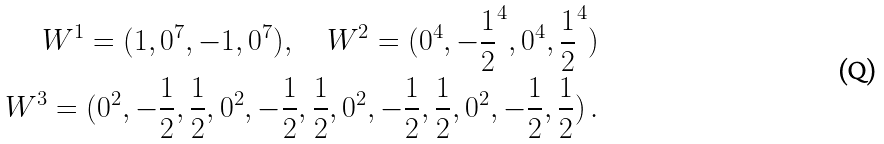<formula> <loc_0><loc_0><loc_500><loc_500>W ^ { 1 } = ( 1 , 0 ^ { 7 } , - 1 , 0 ^ { 7 } ) , \quad W ^ { 2 } = ( 0 ^ { 4 } , { - \frac { 1 } { 2 } } ^ { 4 } , 0 ^ { 4 } , { \frac { 1 } { 2 } } ^ { 4 } ) \\ W ^ { 3 } = ( 0 ^ { 2 } , - \frac { 1 } { 2 } , \frac { 1 } { 2 } , 0 ^ { 2 } , - \frac { 1 } { 2 } , \frac { 1 } { 2 } , 0 ^ { 2 } , - \frac { 1 } { 2 } , \frac { 1 } { 2 } , 0 ^ { 2 } , - \frac { 1 } { 2 } , \frac { 1 } { 2 } ) \, .</formula> 